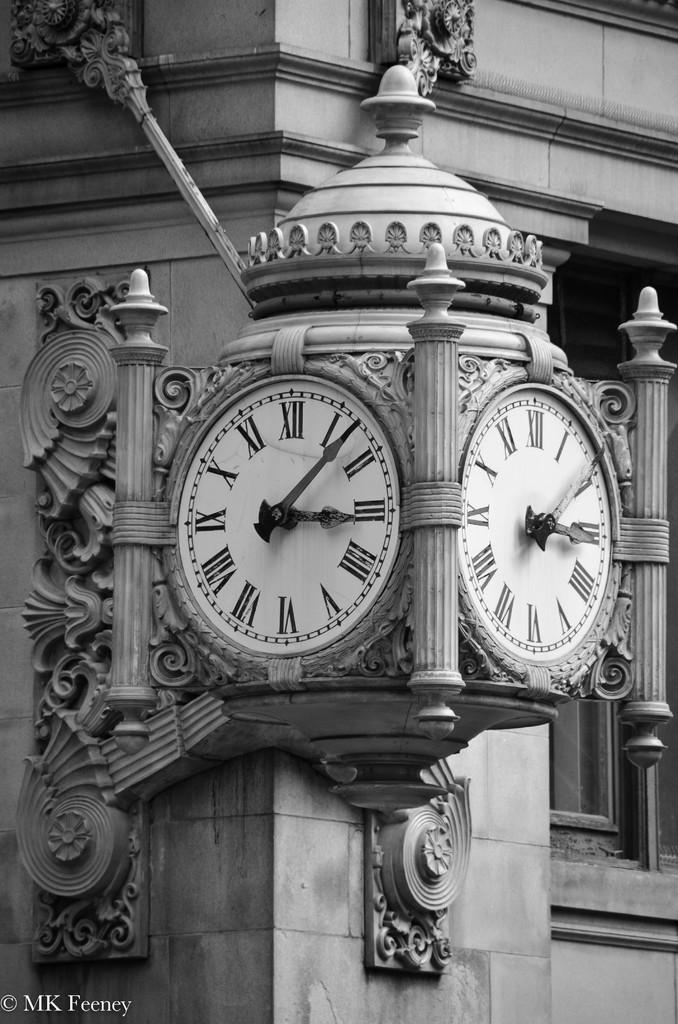Provide a one-sentence caption for the provided image. Old antique clock with the hands on number 3 and 1. 